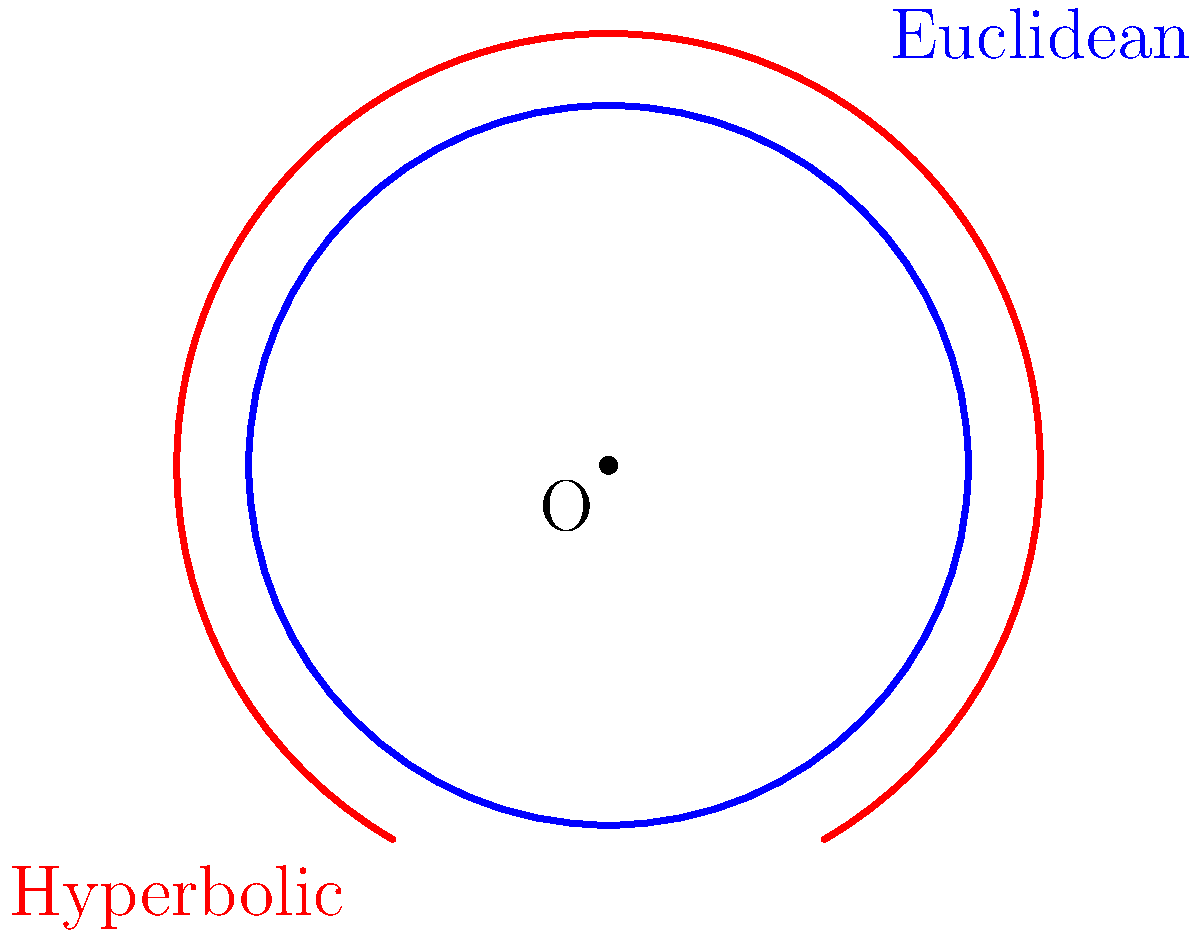In the diagram, the blue circle represents a Euclidean circle, and the red curve represents a hyperbolic circle. How does the ratio of the circumference to the diameter of a circle in hyperbolic geometry compare to the same ratio in Euclidean geometry? Let's approach this step-by-step:

1) In Euclidean geometry, the ratio of a circle's circumference to its diameter is always equal to $\pi$ (approximately 3.14159).

2) This ratio is constant for all circles in Euclidean space, regardless of their size.

3) In hyperbolic geometry, however, this ratio behaves differently:

   a) The ratio of circumference to diameter is always greater than $\pi$.
   
   b) This ratio increases as the circle gets larger.

4) In hyperbolic geometry, as the radius of a circle approaches infinity, the ratio of circumference to diameter also approaches infinity.

5) This is because in hyperbolic space, the circumference of a circle grows exponentially with its radius, while the diameter only grows linearly.

6) Visually, this is represented in the diagram by the red hyperbolic circle appearing more "stretched out" compared to the blue Euclidean circle.

Therefore, in hyperbolic geometry, the ratio of a circle's circumference to its diameter is always greater than $\pi$ and increases with the circle's size, unlike in Euclidean geometry where it remains constant at $\pi$.
Answer: Greater than $\pi$ and increases with circle size 